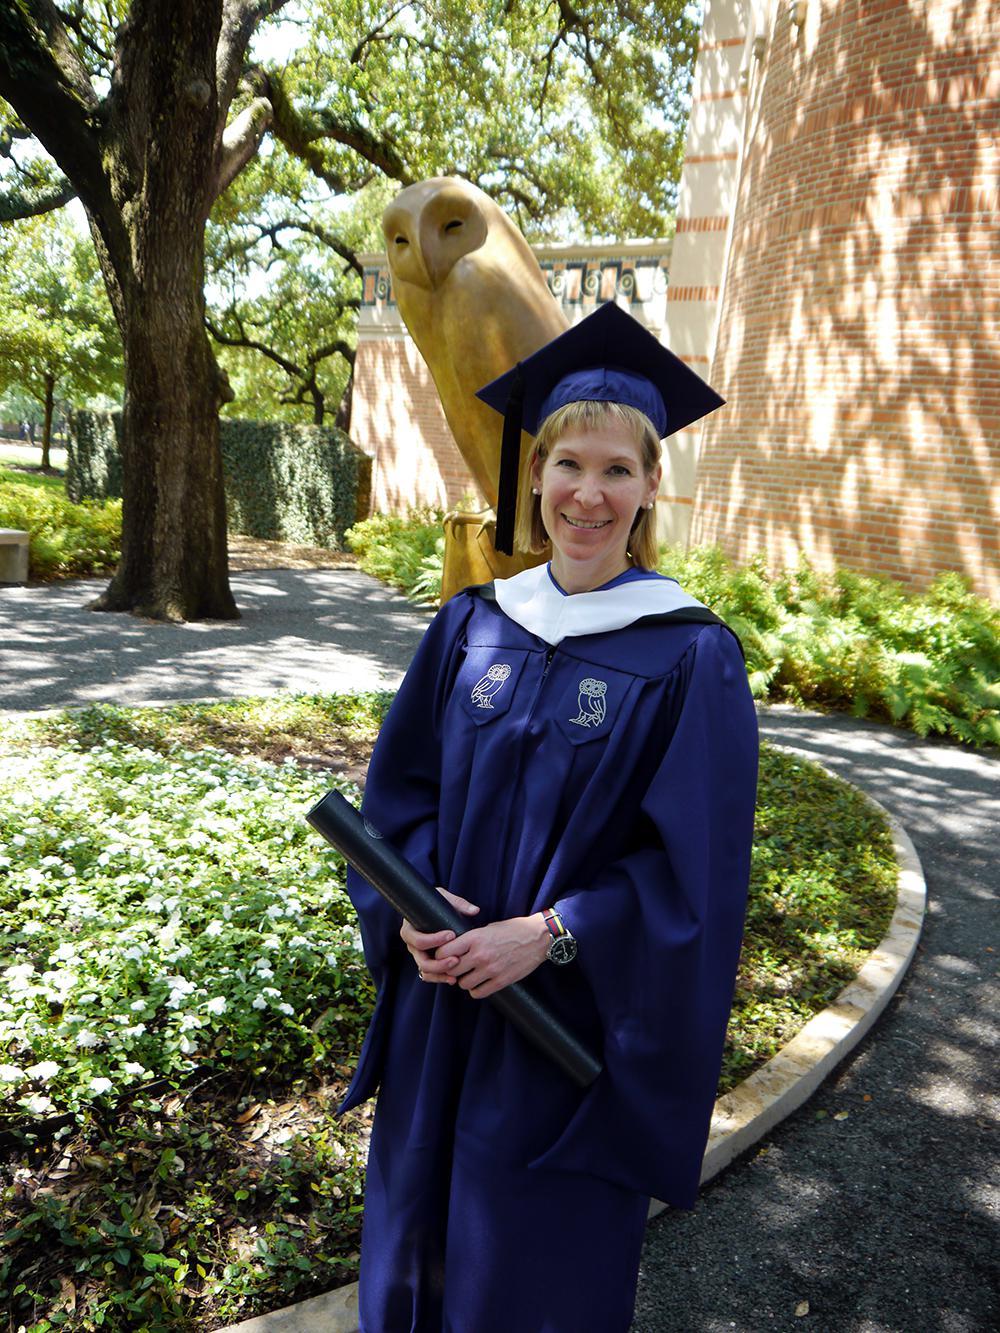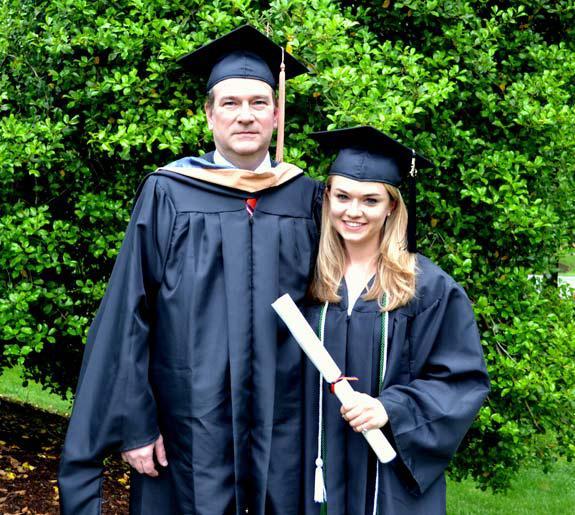The first image is the image on the left, the second image is the image on the right. For the images displayed, is the sentence "And at least one image there is a single female with long white hair holding a rolled up white diploma while still dressed in her cap and gown." factually correct? Answer yes or no. Yes. The first image is the image on the left, the second image is the image on the right. Assess this claim about the two images: "There is exactly one person in cap and gown in the right image.". Correct or not? Answer yes or no. No. 